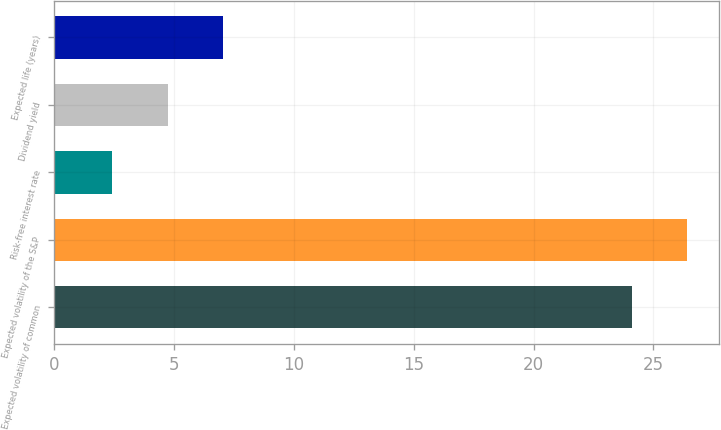Convert chart. <chart><loc_0><loc_0><loc_500><loc_500><bar_chart><fcel>Expected volatility of common<fcel>Expected volatility of the S&P<fcel>Risk-free interest rate<fcel>Dividend yield<fcel>Expected life (years)<nl><fcel>24.1<fcel>26.42<fcel>2.4<fcel>4.72<fcel>7.04<nl></chart> 